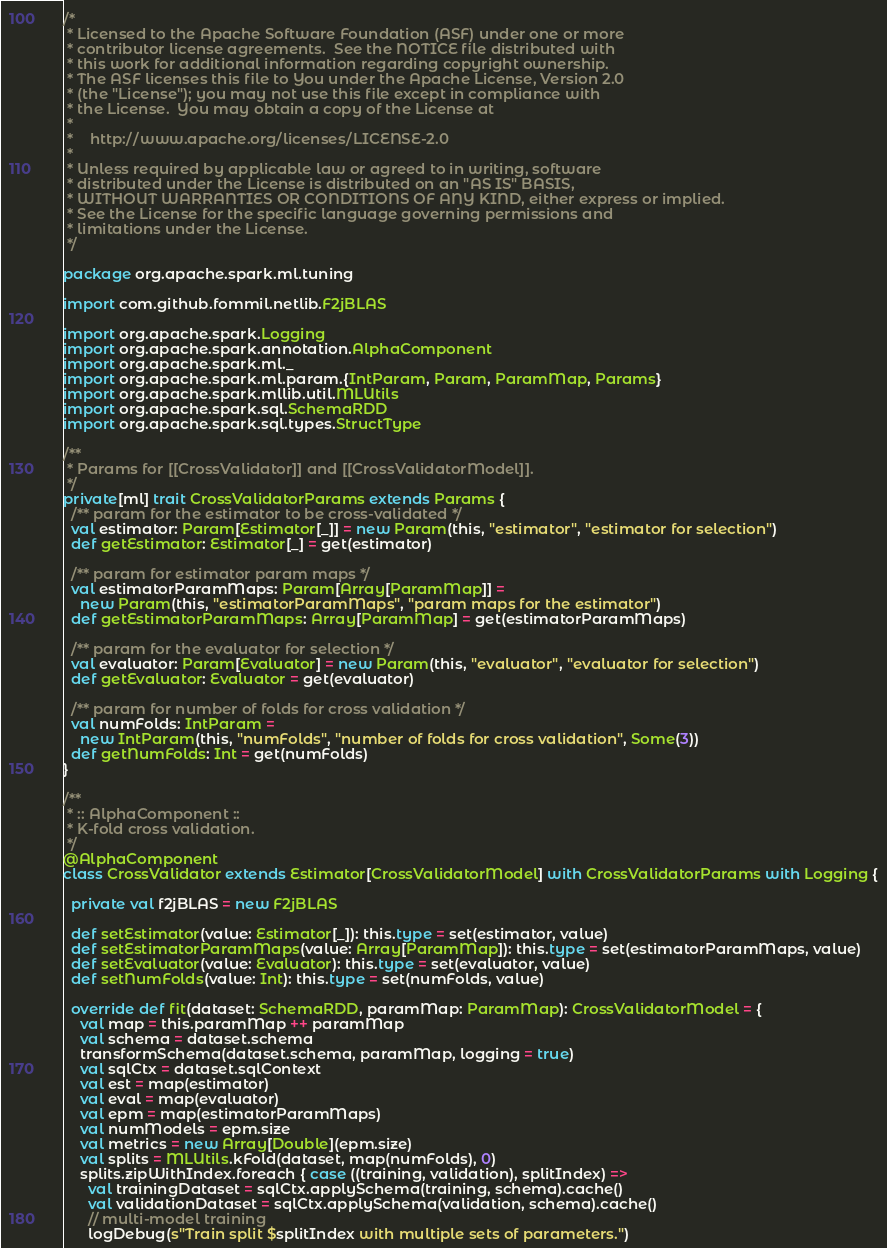Convert code to text. <code><loc_0><loc_0><loc_500><loc_500><_Scala_>/*
 * Licensed to the Apache Software Foundation (ASF) under one or more
 * contributor license agreements.  See the NOTICE file distributed with
 * this work for additional information regarding copyright ownership.
 * The ASF licenses this file to You under the Apache License, Version 2.0
 * (the "License"); you may not use this file except in compliance with
 * the License.  You may obtain a copy of the License at
 *
 *    http://www.apache.org/licenses/LICENSE-2.0
 *
 * Unless required by applicable law or agreed to in writing, software
 * distributed under the License is distributed on an "AS IS" BASIS,
 * WITHOUT WARRANTIES OR CONDITIONS OF ANY KIND, either express or implied.
 * See the License for the specific language governing permissions and
 * limitations under the License.
 */

package org.apache.spark.ml.tuning

import com.github.fommil.netlib.F2jBLAS

import org.apache.spark.Logging
import org.apache.spark.annotation.AlphaComponent
import org.apache.spark.ml._
import org.apache.spark.ml.param.{IntParam, Param, ParamMap, Params}
import org.apache.spark.mllib.util.MLUtils
import org.apache.spark.sql.SchemaRDD
import org.apache.spark.sql.types.StructType

/**
 * Params for [[CrossValidator]] and [[CrossValidatorModel]].
 */
private[ml] trait CrossValidatorParams extends Params {
  /** param for the estimator to be cross-validated */
  val estimator: Param[Estimator[_]] = new Param(this, "estimator", "estimator for selection")
  def getEstimator: Estimator[_] = get(estimator)

  /** param for estimator param maps */
  val estimatorParamMaps: Param[Array[ParamMap]] =
    new Param(this, "estimatorParamMaps", "param maps for the estimator")
  def getEstimatorParamMaps: Array[ParamMap] = get(estimatorParamMaps)

  /** param for the evaluator for selection */
  val evaluator: Param[Evaluator] = new Param(this, "evaluator", "evaluator for selection")
  def getEvaluator: Evaluator = get(evaluator)

  /** param for number of folds for cross validation */
  val numFolds: IntParam =
    new IntParam(this, "numFolds", "number of folds for cross validation", Some(3))
  def getNumFolds: Int = get(numFolds)
}

/**
 * :: AlphaComponent ::
 * K-fold cross validation.
 */
@AlphaComponent
class CrossValidator extends Estimator[CrossValidatorModel] with CrossValidatorParams with Logging {

  private val f2jBLAS = new F2jBLAS

  def setEstimator(value: Estimator[_]): this.type = set(estimator, value)
  def setEstimatorParamMaps(value: Array[ParamMap]): this.type = set(estimatorParamMaps, value)
  def setEvaluator(value: Evaluator): this.type = set(evaluator, value)
  def setNumFolds(value: Int): this.type = set(numFolds, value)

  override def fit(dataset: SchemaRDD, paramMap: ParamMap): CrossValidatorModel = {
    val map = this.paramMap ++ paramMap
    val schema = dataset.schema
    transformSchema(dataset.schema, paramMap, logging = true)
    val sqlCtx = dataset.sqlContext
    val est = map(estimator)
    val eval = map(evaluator)
    val epm = map(estimatorParamMaps)
    val numModels = epm.size
    val metrics = new Array[Double](epm.size)
    val splits = MLUtils.kFold(dataset, map(numFolds), 0)
    splits.zipWithIndex.foreach { case ((training, validation), splitIndex) =>
      val trainingDataset = sqlCtx.applySchema(training, schema).cache()
      val validationDataset = sqlCtx.applySchema(validation, schema).cache()
      // multi-model training
      logDebug(s"Train split $splitIndex with multiple sets of parameters.")</code> 